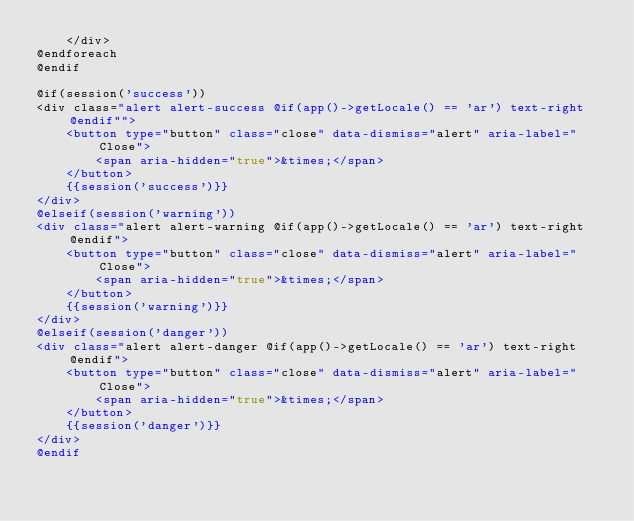<code> <loc_0><loc_0><loc_500><loc_500><_PHP_>    </div>
@endforeach
@endif

@if(session('success'))
<div class="alert alert-success @if(app()->getLocale() == 'ar') text-right @endif"">
    <button type="button" class="close" data-dismiss="alert" aria-label="Close">
        <span aria-hidden="true">&times;</span>
    </button>
    {{session('success')}}
</div>
@elseif(session('warning'))
<div class="alert alert-warning @if(app()->getLocale() == 'ar') text-right @endif">
    <button type="button" class="close" data-dismiss="alert" aria-label="Close">
        <span aria-hidden="true">&times;</span>
    </button>
    {{session('warning')}}
</div>
@elseif(session('danger'))
<div class="alert alert-danger @if(app()->getLocale() == 'ar') text-right @endif">
    <button type="button" class="close" data-dismiss="alert" aria-label="Close">
        <span aria-hidden="true">&times;</span>
    </button>
    {{session('danger')}}
</div>
@endif</code> 